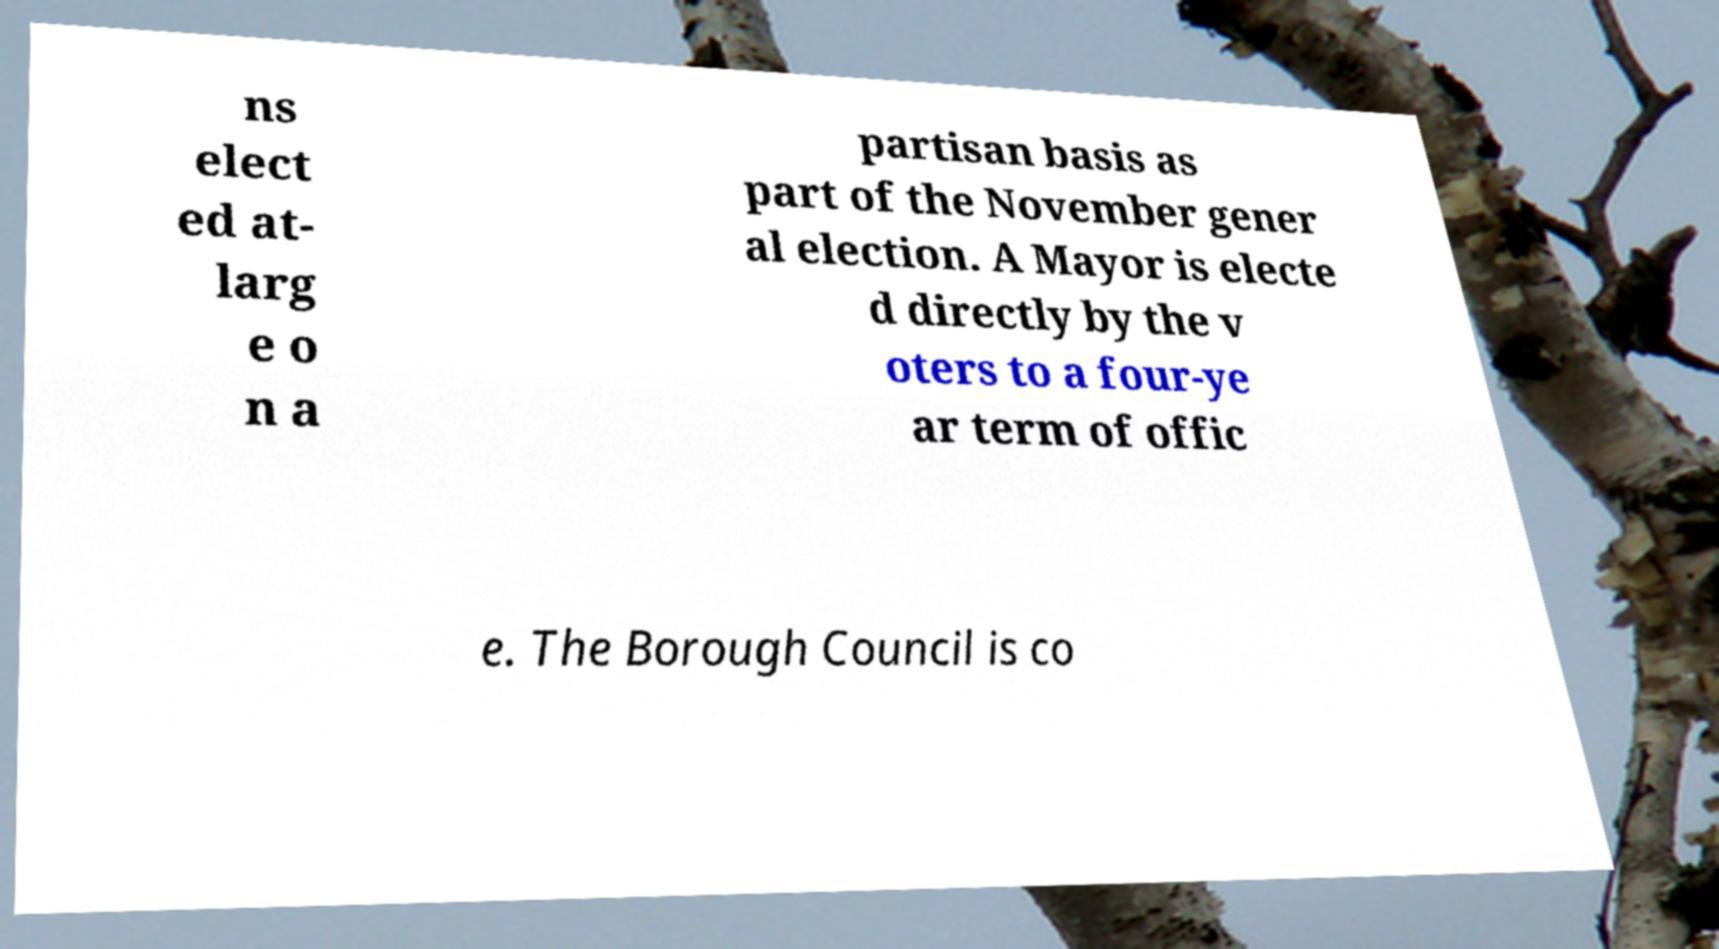Could you extract and type out the text from this image? ns elect ed at- larg e o n a partisan basis as part of the November gener al election. A Mayor is electe d directly by the v oters to a four-ye ar term of offic e. The Borough Council is co 